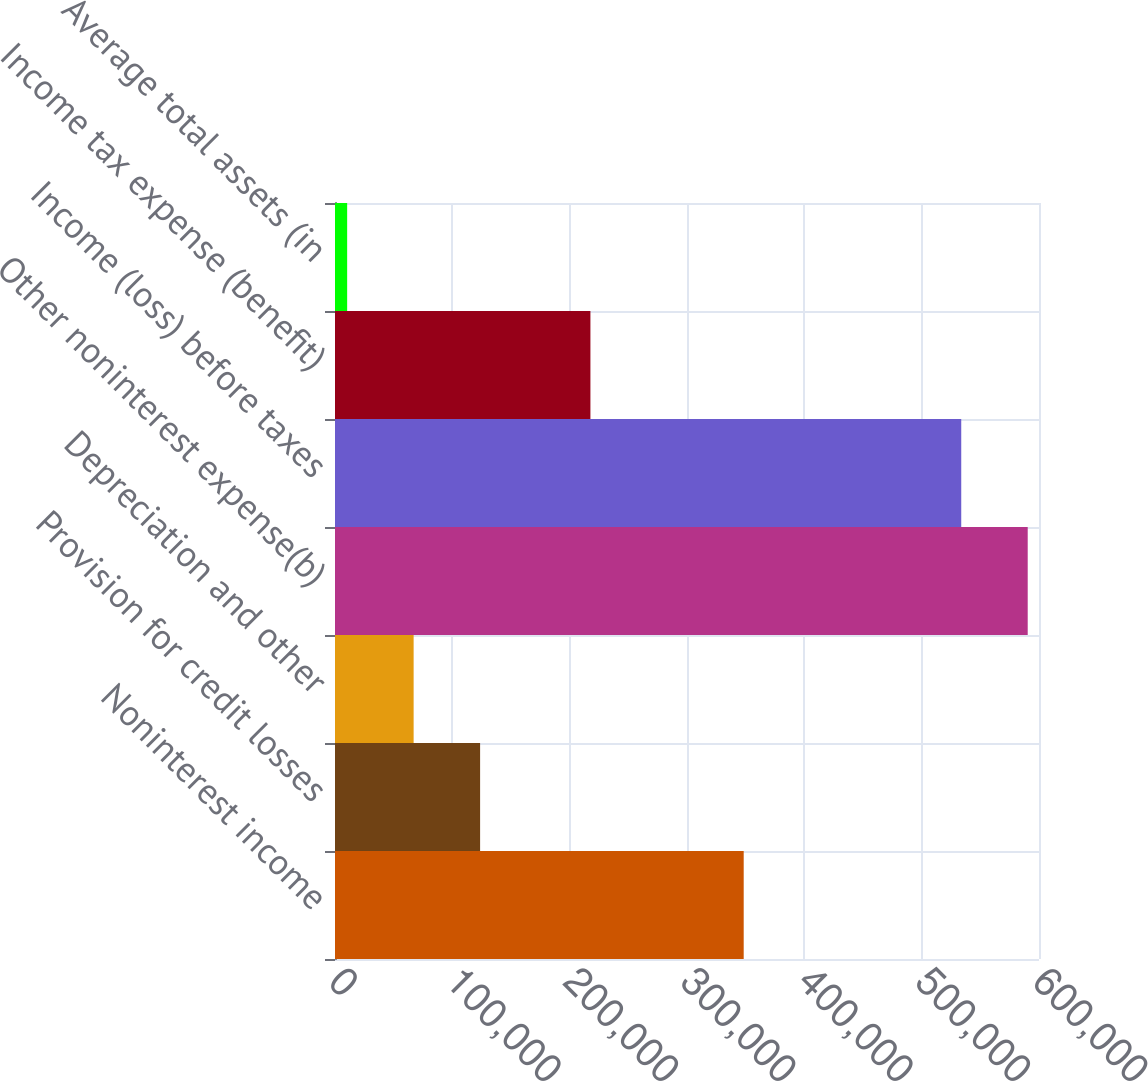Convert chart to OTSL. <chart><loc_0><loc_0><loc_500><loc_500><bar_chart><fcel>Noninterest income<fcel>Provision for credit losses<fcel>Depreciation and other<fcel>Other noninterest expense(b)<fcel>Income (loss) before taxes<fcel>Income tax expense (benefit)<fcel>Average total assets (in<nl><fcel>348324<fcel>123669<fcel>67014.4<fcel>590381<fcel>533727<fcel>217681<fcel>10360<nl></chart> 